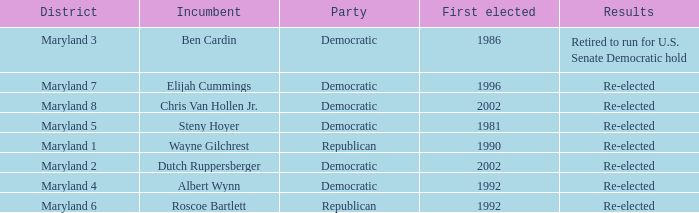What are the results of the incumbent who was first elected in 1996? Re-elected. 